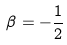Convert formula to latex. <formula><loc_0><loc_0><loc_500><loc_500>\beta = - \frac { 1 } { 2 }</formula> 